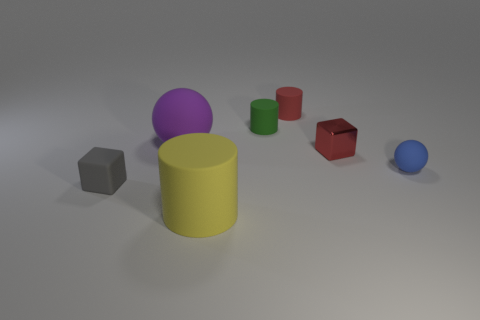How many spheres are both in front of the red metallic cube and on the left side of the blue matte object?
Ensure brevity in your answer.  0. The tiny metallic cube is what color?
Provide a short and direct response. Red. There is a tiny blue thing that is the same shape as the big purple thing; what is its material?
Your answer should be very brief. Rubber. Is there any other thing that is the same material as the purple sphere?
Provide a short and direct response. Yes. Is the color of the metal thing the same as the small ball?
Offer a very short reply. No. The large rubber object that is on the right side of the purple thing that is on the left side of the metal object is what shape?
Give a very brief answer. Cylinder. What is the shape of the large purple object that is made of the same material as the green thing?
Make the answer very short. Sphere. What number of other things are there of the same shape as the large purple thing?
Offer a terse response. 1. There is a green matte cylinder that is behind the metal object; does it have the same size as the metal thing?
Make the answer very short. Yes. Are there more blue matte objects that are in front of the small blue sphere than yellow cylinders?
Offer a very short reply. No. 